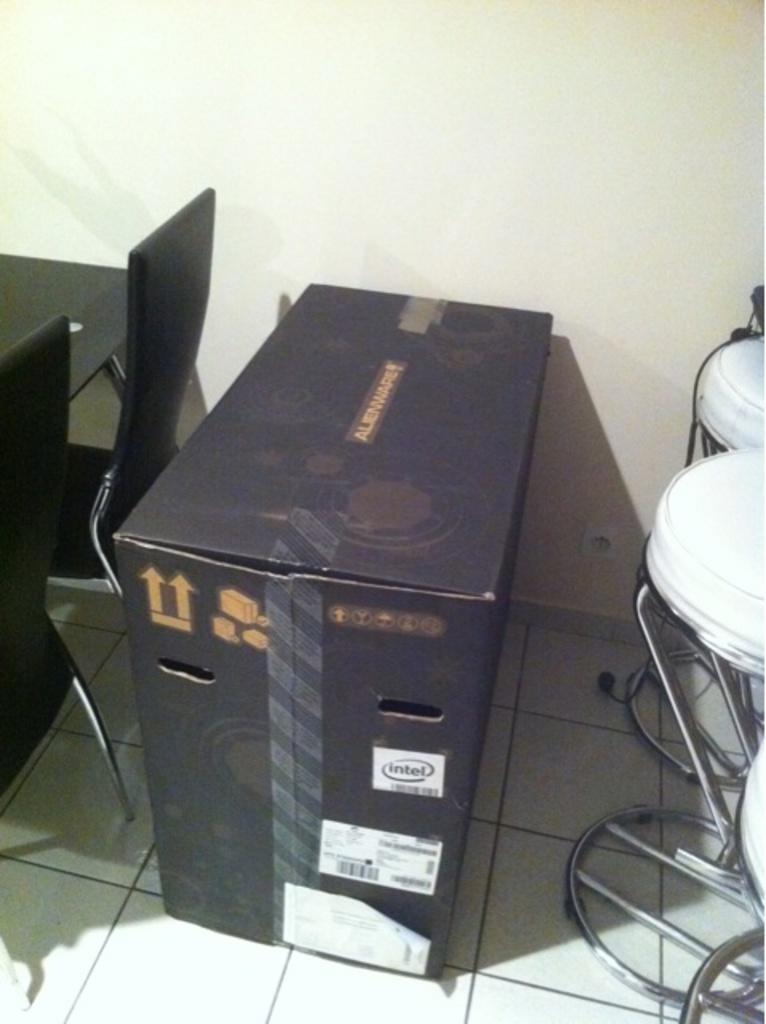In one or two sentences, can you explain what this image depicts? In this picture there is a cardboard box and there is text on the box and there are chairs and there is a table. At the bottom there is a floor. At the back there is a wall. 